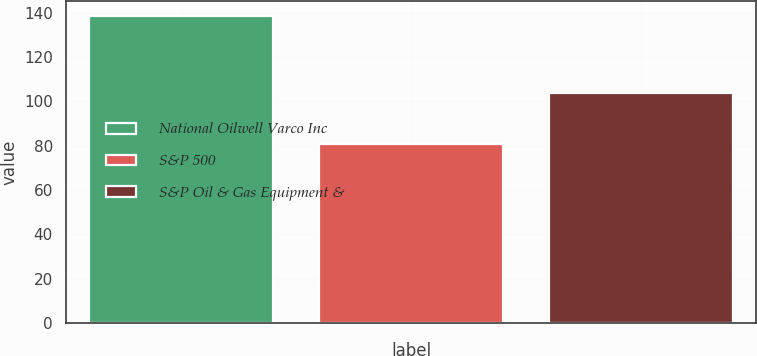Convert chart to OTSL. <chart><loc_0><loc_0><loc_500><loc_500><bar_chart><fcel>National Oilwell Varco Inc<fcel>S&P 500<fcel>S&P Oil & Gas Equipment &<nl><fcel>138.51<fcel>80.74<fcel>103.64<nl></chart> 